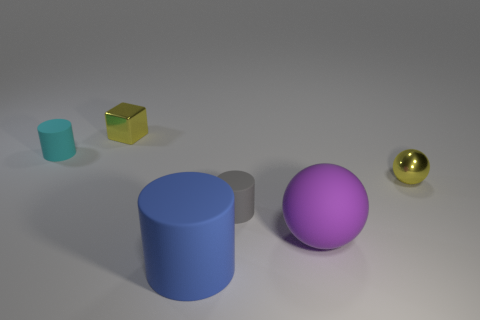How many objects are either things on the left side of the big ball or purple metal things?
Give a very brief answer. 4. How many things are left of the yellow thing left of the blue matte cylinder?
Your answer should be very brief. 1. There is a matte thing behind the tiny yellow metal object that is to the right of the small metallic thing that is behind the cyan object; how big is it?
Make the answer very short. Small. There is a large matte thing on the left side of the big sphere; does it have the same color as the large matte ball?
Ensure brevity in your answer.  No. The gray object that is the same shape as the blue thing is what size?
Provide a succinct answer. Small. How many things are tiny yellow metallic objects behind the cyan object or tiny rubber cylinders in front of the tiny cyan cylinder?
Give a very brief answer. 2. The matte thing that is behind the tiny yellow shiny object in front of the tiny cyan cylinder is what shape?
Make the answer very short. Cylinder. Is there any other thing that has the same color as the matte sphere?
Make the answer very short. No. How many things are either cyan cylinders or metal things?
Your answer should be very brief. 3. Are there any yellow matte balls of the same size as the yellow metal block?
Provide a succinct answer. No. 